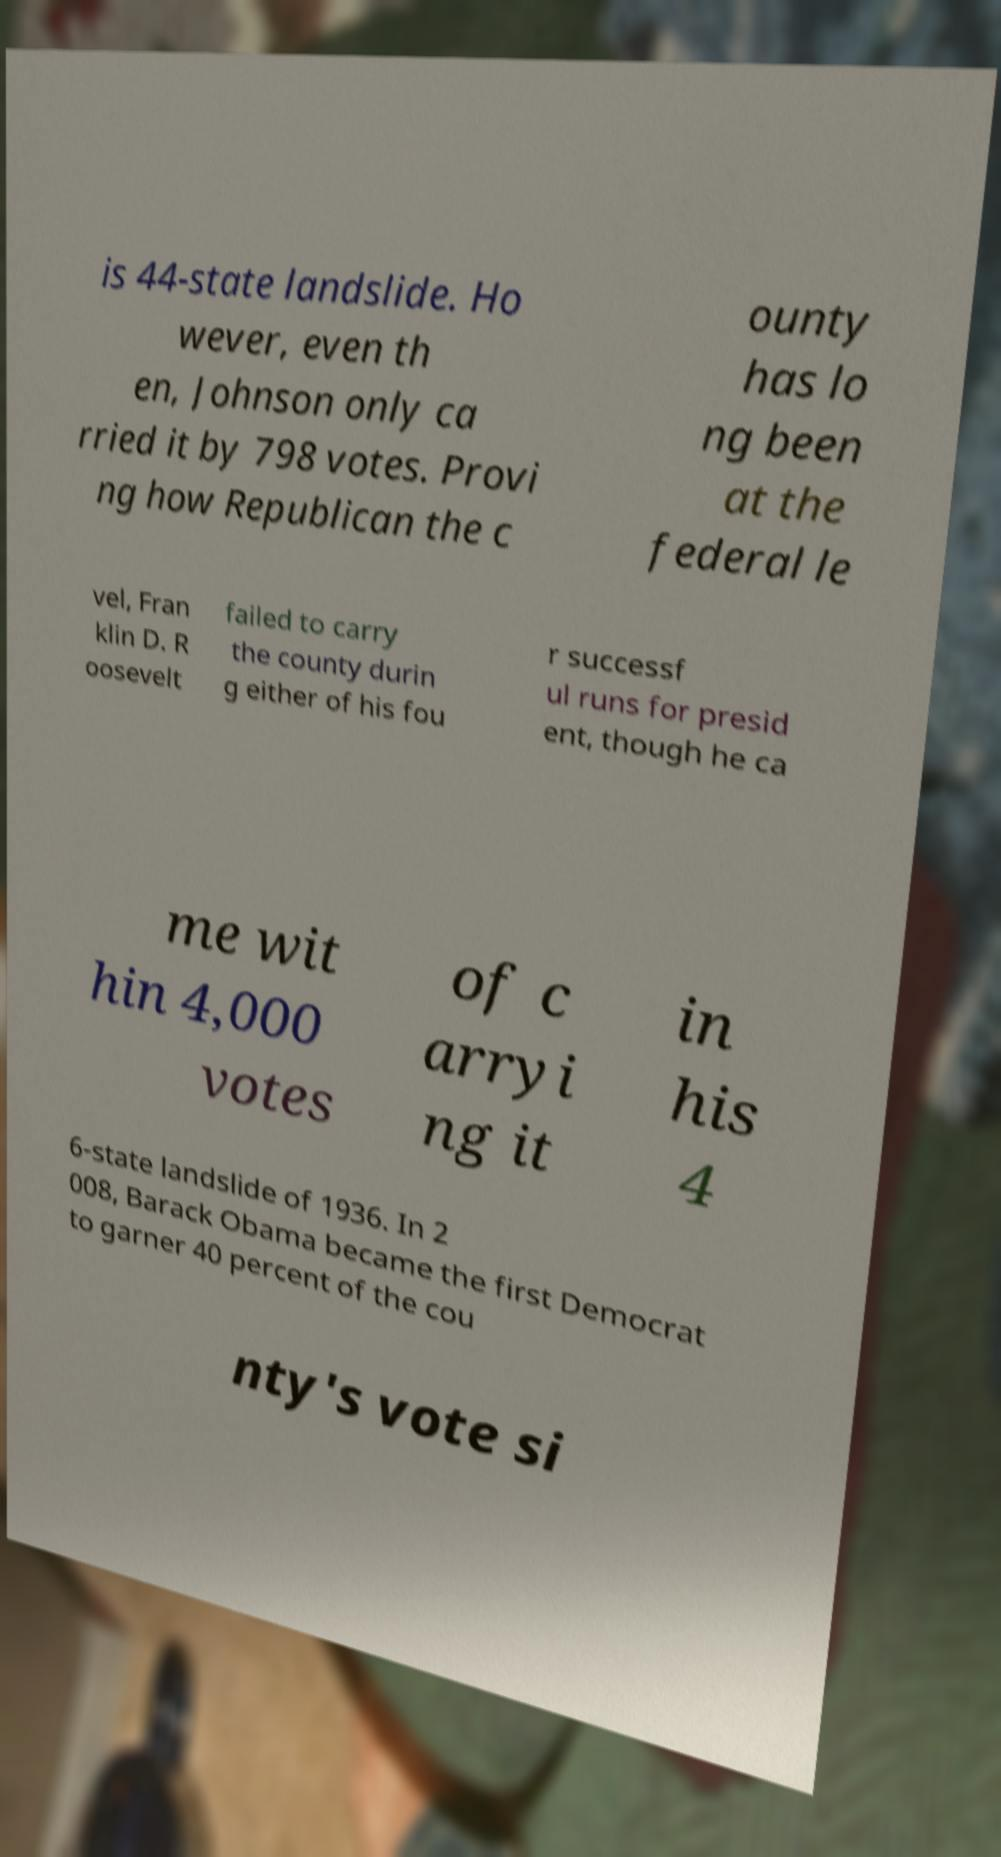Please identify and transcribe the text found in this image. is 44-state landslide. Ho wever, even th en, Johnson only ca rried it by 798 votes. Provi ng how Republican the c ounty has lo ng been at the federal le vel, Fran klin D. R oosevelt failed to carry the county durin g either of his fou r successf ul runs for presid ent, though he ca me wit hin 4,000 votes of c arryi ng it in his 4 6-state landslide of 1936. In 2 008, Barack Obama became the first Democrat to garner 40 percent of the cou nty's vote si 